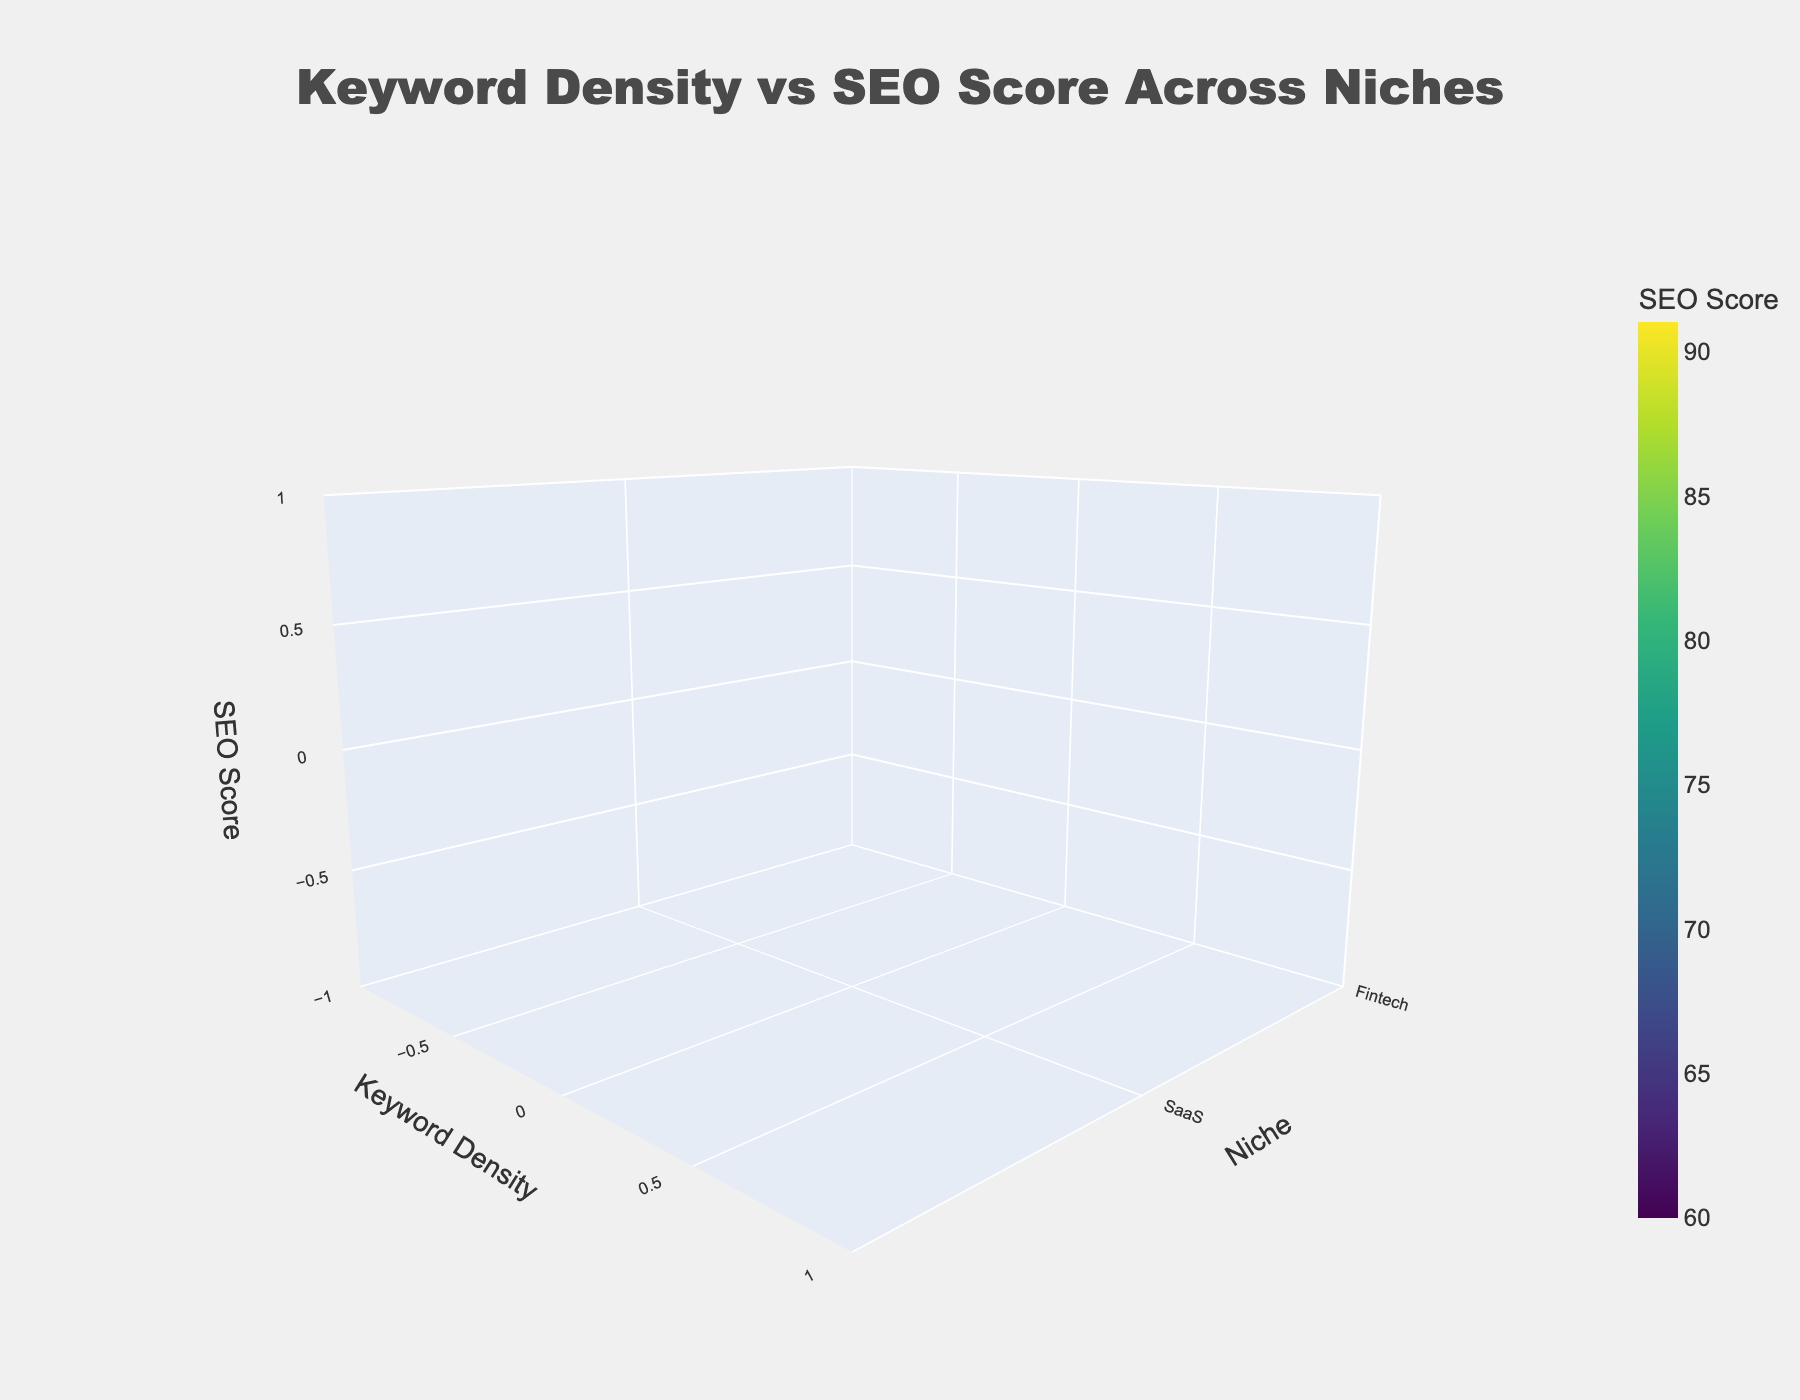What is the title of the 3D surface plot? The title is generally displayed at the top of the plot. In this case, the title should be located prominently and easily readable.
Answer: Keyword Density vs SEO Score Across Niches What are the axes labels in the plot? The labels for the axes are specified to indicate what each axis represents. In this figure, the x-axis represents "Keyword Density," the y-axis represents "Niche," and the z-axis represents "SEO Score."
Answer: Keyword Density, Niche, SEO Score Which niche appears to have the highest SEO Score for the highest Keyword Density? Examine the plot to see which point along the y-axis corresponds to the highest z-axis value near the highest x-axis value of Keyword Density. In this case, the highest SEO Score for the highest Keyword Density is observed for the SaaS niche.
Answer: SaaS Considering the entire range of Keyword Densities, which niche generally shows the lowest SEO Scores? By comparing the overall shape and height of the surface (z-axis values) for each niche (y-axis), the Health_Tech niche generally has the lowest SEO Scores.
Answer: Health_Tech What is the relationship trend between Keyword Density and SEO Score across all niches? The trend can be observed by looking at the surface plot's shape from lower to higher Keyword Density values. There is a general upward trend indicating that as Keyword Density increases, SEO Score tends to increase across different niches.
Answer: Positive Correlation For which niche is the difference in SEO Score between Keyword Densities of 1.2 and 2.1 the highest? Compare the SEO Score values at Keyword Density 1.2 and Keyword Density 2.1 across all niches and find the difference. The niche with the largest difference is AI_ML.
Answer: AI_ML How does the SEO Score for E-commerce change with increasing Keyword Density? Notice the change in the z-axis value as Keyword Density (x-axis) increases for the E-commerce niche. The SEO Score for E-commerce increases as Keyword Density increases.
Answer: Increases Which niche has the most gradual increase in SEO Score with increasing Keyword Density? A gradual increase means a relatively flat slope compared to others. Upon examining the surfaces, the Health_Tech niche shows the most gradual increase in SEO Score with increasing Keyword Density.
Answer: Health_Tech What is the approximate SEO Score for Fintech at Keyword Density 1.6? Locate the point where Fintech (on the y-axis) intersects with Keyword Density 1.6 (on the x-axis) and read the corresponding z-axis value. The approximate SEO Score for Fintech at Keyword Density 1.6 is 76.
Answer: 76 Comparing AI_ML and Health_Tech, which niche has higher SEO Scores at Keyword Density 1.5? Check the z-axis values at x-axis value 1.5 for both AI_ML and Health_Tech. AI_ML has higher SEO Scores at this Keyword Density.
Answer: AI_ML 